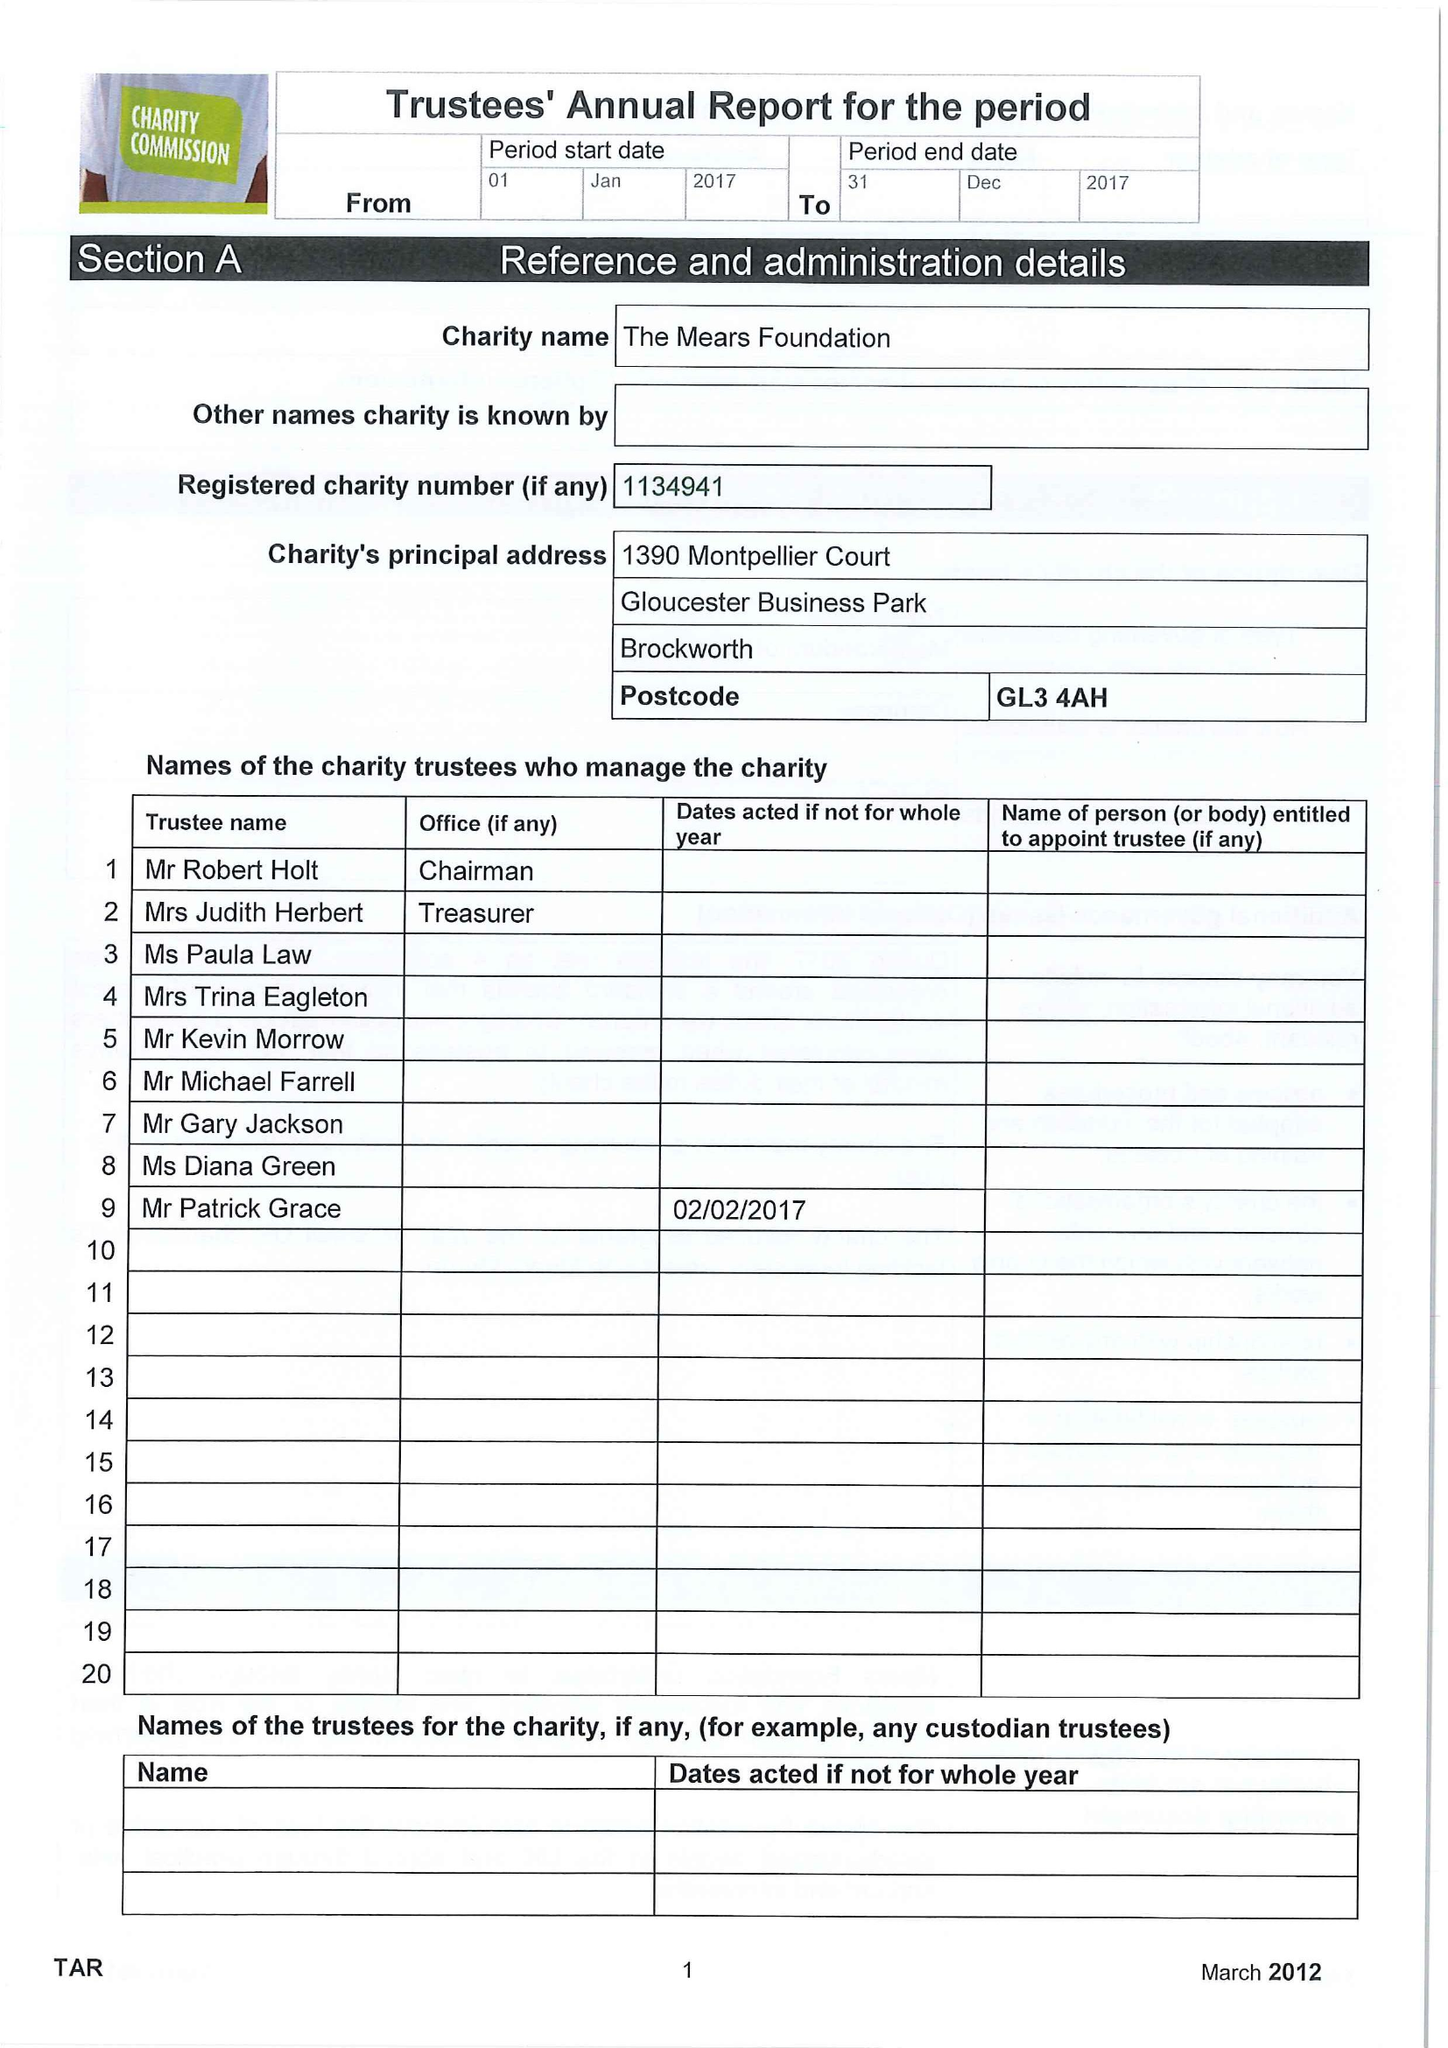What is the value for the spending_annually_in_british_pounds?
Answer the question using a single word or phrase. 13049.00 